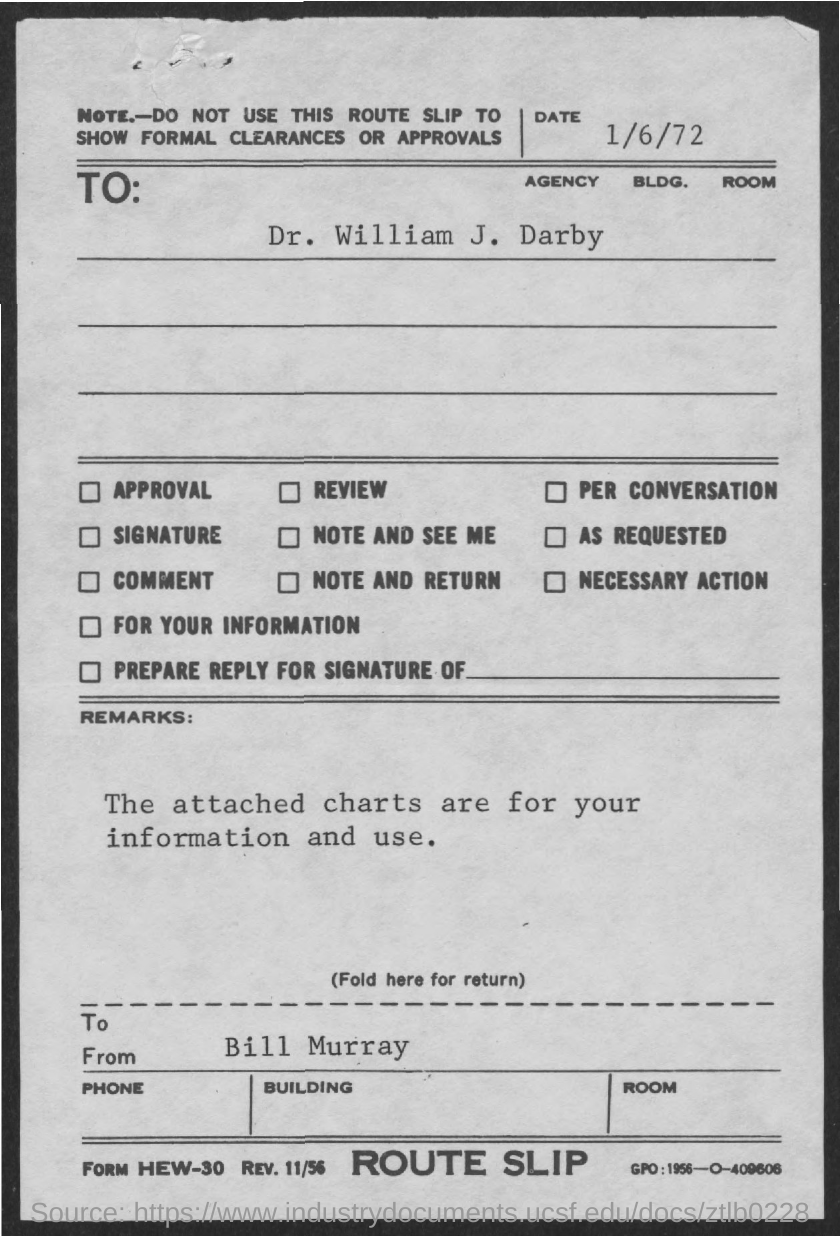Identify some key points in this picture. The date mentioned is 1/6/72. The type of slip involved is a route slip. The remark "What is the remarks?" refers to a request for clarification or information, specifically asking about the purpose and usage of attached charts. This slip is not intended for showing formal clearances or approvals, but rather for providing a note. 